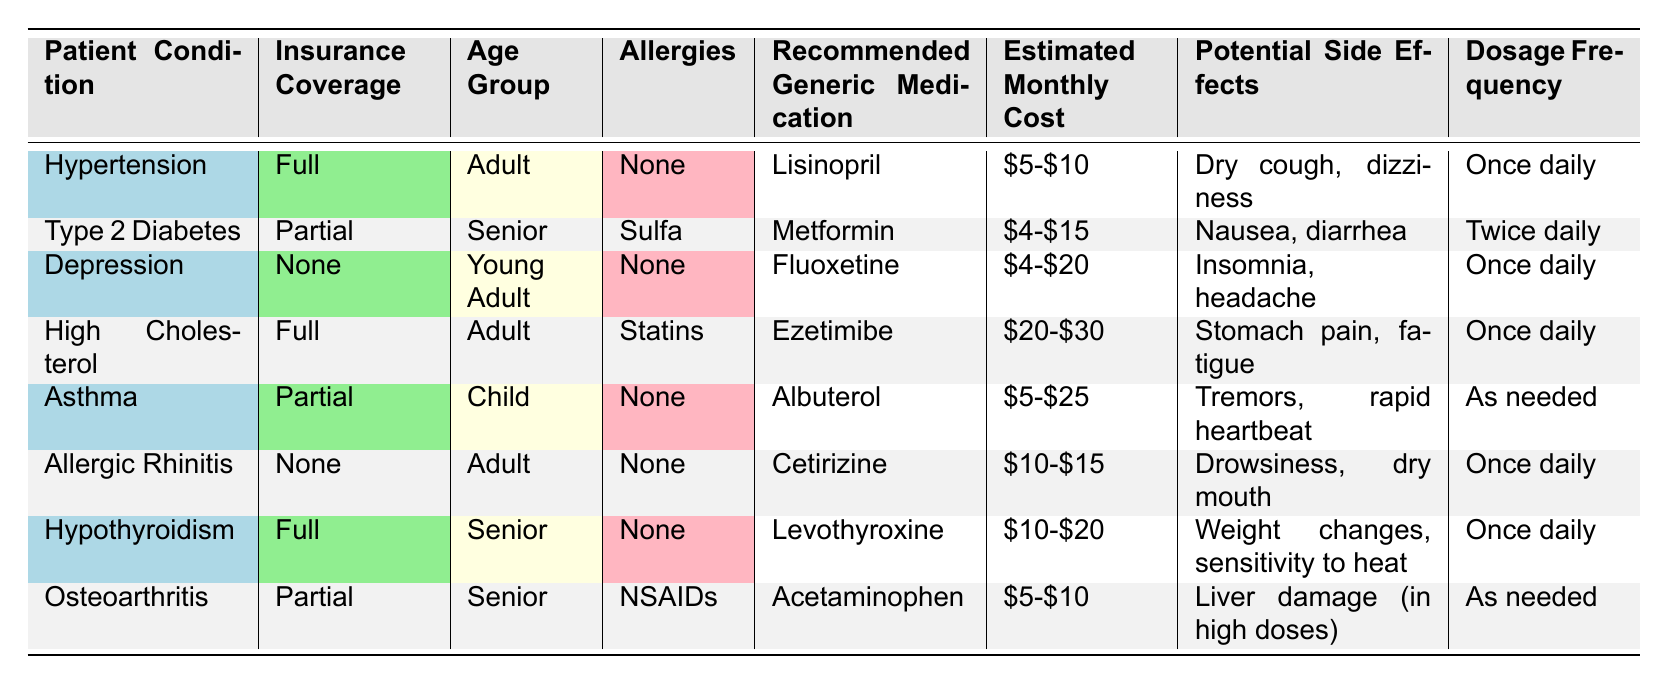What is the recommended generic medication for hypertension? According to the table, the recommended generic medication for hypertension is listed under the "Patient Condition" column specifically for that condition. The entry shows "Lisinopril."
Answer: Lisinopril What are the potential side effects of Metformin? Looking at the table, we find the row for "Type 2 Diabetes," which indicates that the recommended generic medication is Metformin. The corresponding "Potential Side Effects" column for this row lists "Nausea, diarrhea."
Answer: Nausea, diarrhea Is Lisinopril recommended for patients with allergies to sulfa? By examining the table, we can see that Lisinopril is recommended for hypertension, where there are no allergies mentioned. However, Metformin is for Type 2 Diabetes and is noted for having a sulfa allergy. Therefore, Lisinopril doesn't have any such contraindication based on allergies.
Answer: Yes What is the estimated cost range for Albuterol? In the "Asthma" row of the table, the column labeled "Estimated Monthly Cost" specifies that Albuterol costs between "$5-$25."
Answer: $5-$25 Which medication has the highest estimated monthly cost, and what is that cost? We need to inspect the "Estimated Monthly Cost" column for each medication. The highest cost indicated is for Ezetimibe, listed as "$20-$30."
Answer: $20-$30 Is there a medication listed for allergic rhinitis? If so, what is it? Referring to the table, we check the "Patient Condition" column for "Allergic Rhinitis" and find the recommended medication "Cetirizine" under that condition.
Answer: Yes, Cetirizine How frequently should Levothyroxine be taken? According to the table, the row corresponding to "Hypothyroidism" specifies in the "Dosage Frequency" column that Levothyroxine should be taken "Once daily."
Answer: Once daily What is the age group for the recommended medication for high cholesterol? The table indicates that for the condition concerning "High Cholesterol," the age group falls under "Adult." This is found in the "Age Group" column of that specific row.
Answer: Adult Which medications can be taken as needed, and what are their patient conditions? Analyzing the table, we find that "Albuterol" is recommended for "Asthma," and "Acetaminophen" is listed for "Osteoarthritis," both of which can be taken as needed as stated in the "Dosage Frequency" column.
Answer: Albuterol (Asthma), Acetaminophen (Osteoarthritis) 